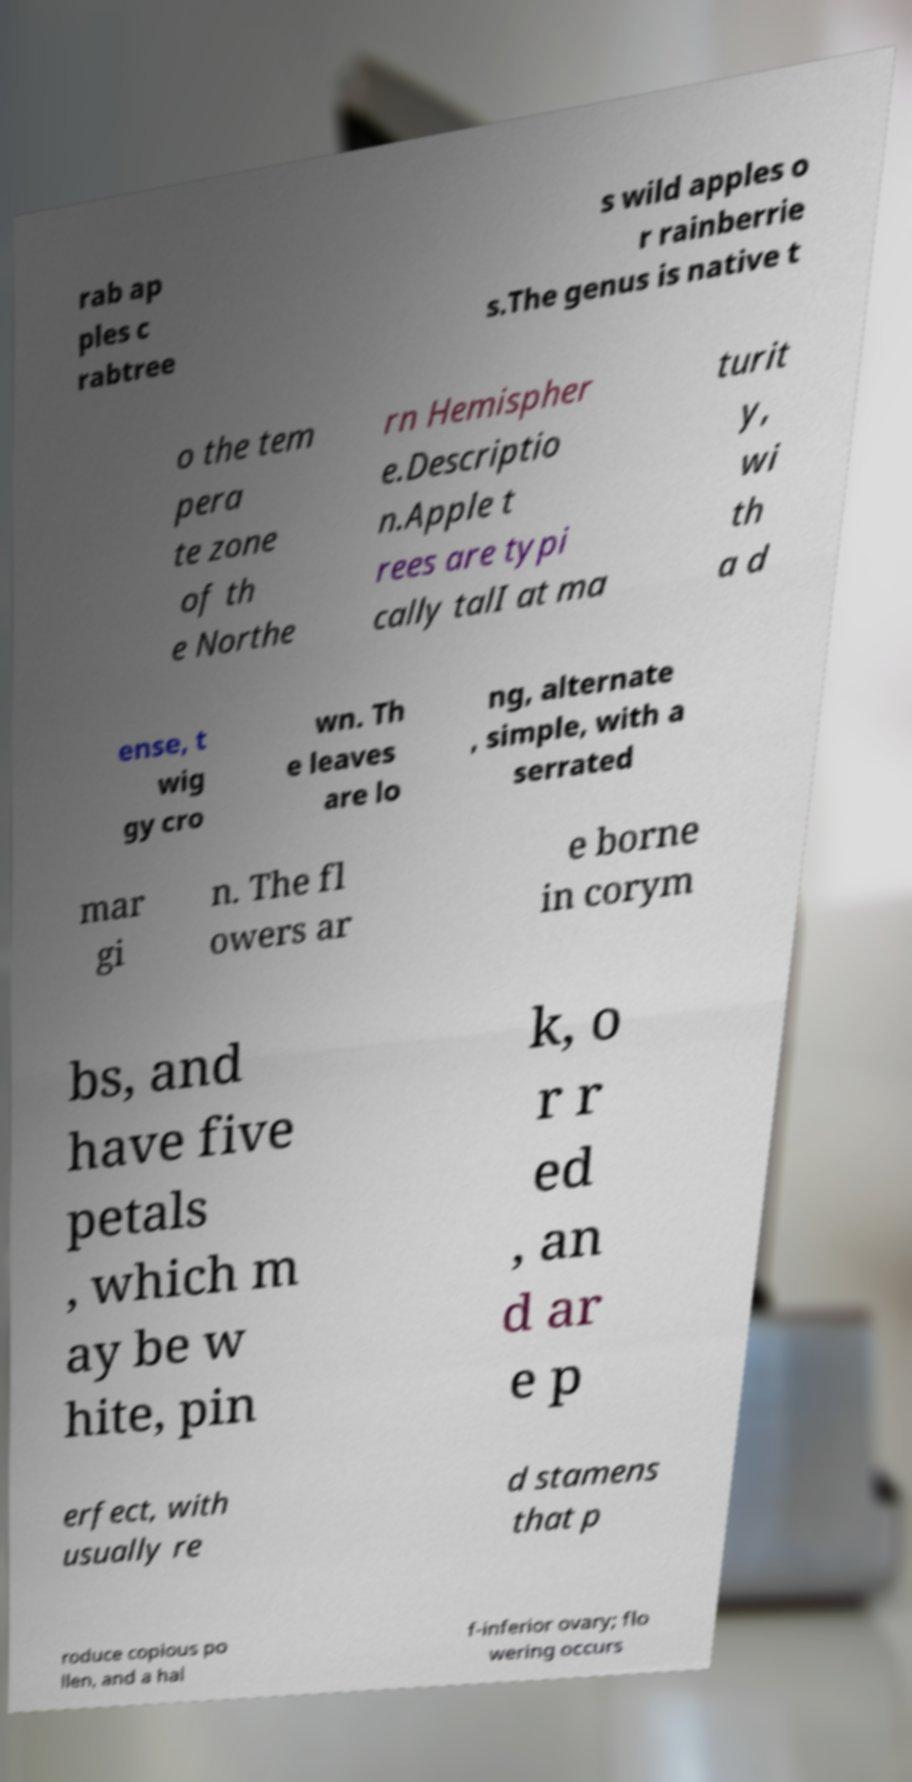Please read and relay the text visible in this image. What does it say? rab ap ples c rabtree s wild apples o r rainberrie s.The genus is native t o the tem pera te zone of th e Northe rn Hemispher e.Descriptio n.Apple t rees are typi cally talI at ma turit y, wi th a d ense, t wig gy cro wn. Th e leaves are lo ng, alternate , simple, with a serrated mar gi n. The fl owers ar e borne in corym bs, and have five petals , which m ay be w hite, pin k, o r r ed , an d ar e p erfect, with usually re d stamens that p roduce copious po llen, and a hal f-inferior ovary; flo wering occurs 